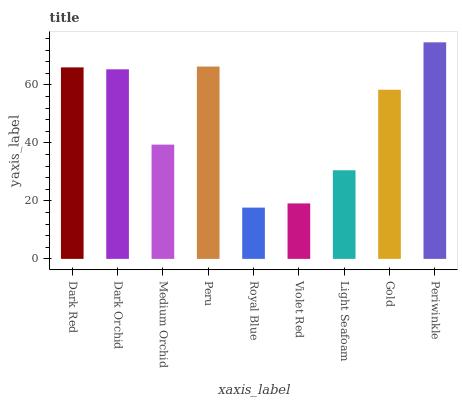Is Royal Blue the minimum?
Answer yes or no. Yes. Is Periwinkle the maximum?
Answer yes or no. Yes. Is Dark Orchid the minimum?
Answer yes or no. No. Is Dark Orchid the maximum?
Answer yes or no. No. Is Dark Red greater than Dark Orchid?
Answer yes or no. Yes. Is Dark Orchid less than Dark Red?
Answer yes or no. Yes. Is Dark Orchid greater than Dark Red?
Answer yes or no. No. Is Dark Red less than Dark Orchid?
Answer yes or no. No. Is Gold the high median?
Answer yes or no. Yes. Is Gold the low median?
Answer yes or no. Yes. Is Medium Orchid the high median?
Answer yes or no. No. Is Dark Red the low median?
Answer yes or no. No. 